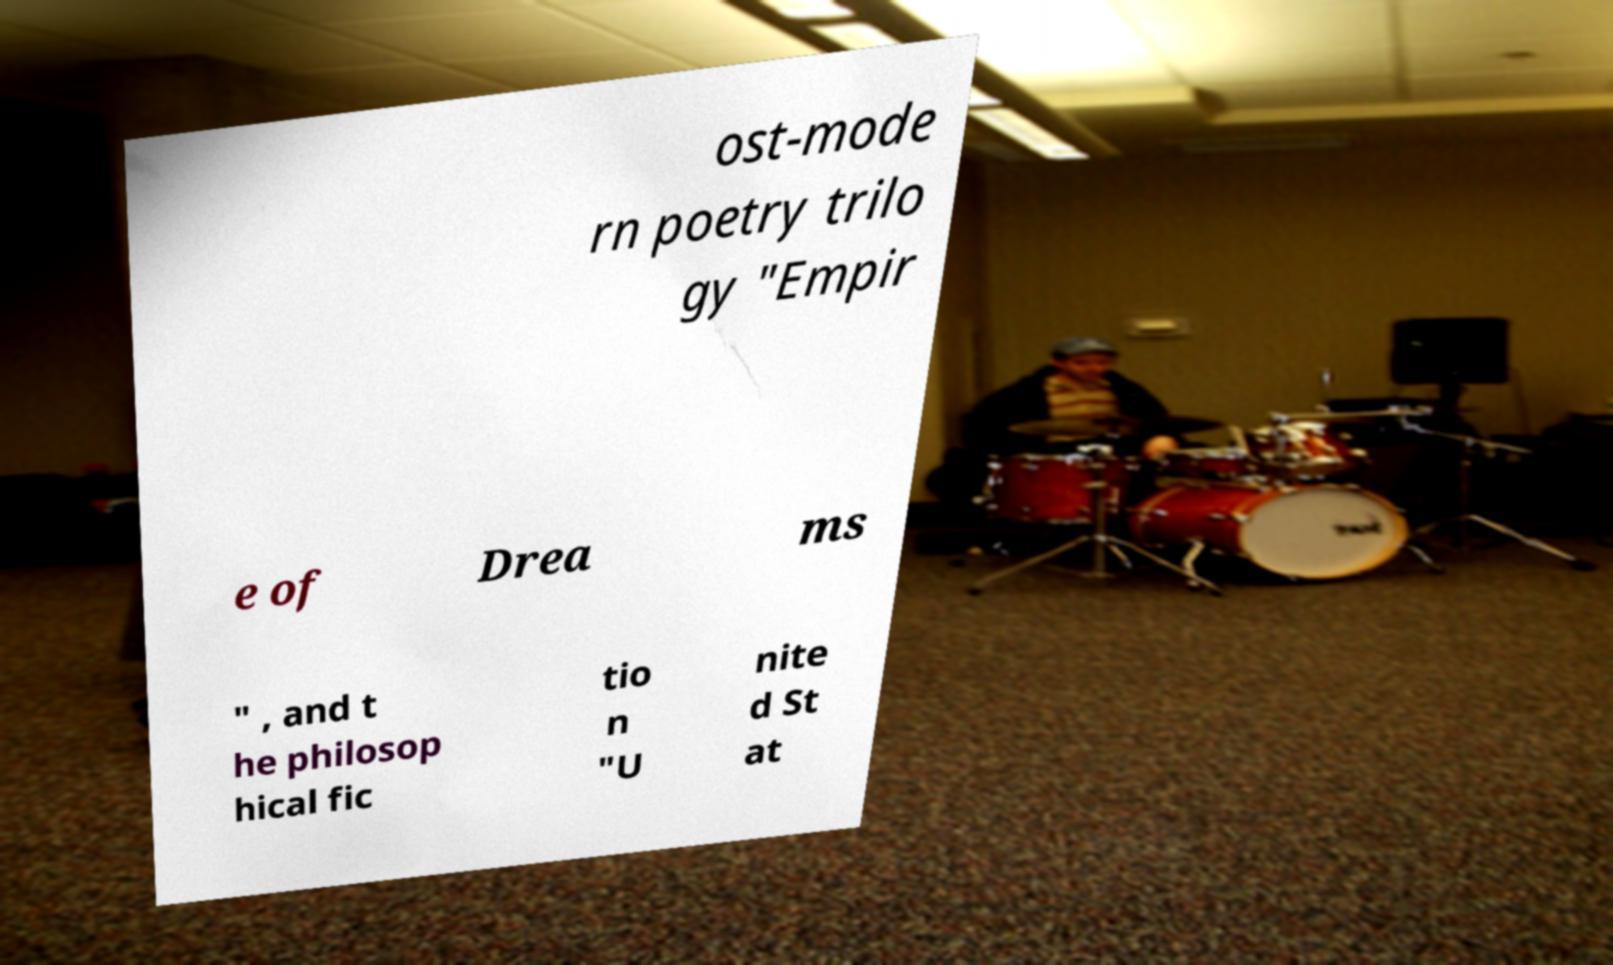I need the written content from this picture converted into text. Can you do that? ost-mode rn poetry trilo gy "Empir e of Drea ms " , and t he philosop hical fic tio n "U nite d St at 